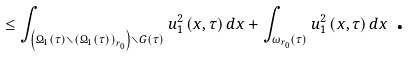Convert formula to latex. <formula><loc_0><loc_0><loc_500><loc_500>\leq \int \nolimits _ { \left ( \Omega _ { 1 } \left ( \tau \right ) \smallsetminus \left ( \Omega _ { 1 } \left ( \tau \right ) \right ) _ { r _ { 0 } } \right ) \smallsetminus G \left ( \tau \right ) } u _ { 1 } ^ { 2 } \left ( x , \tau \right ) d x + \int \nolimits _ { \omega _ { r _ { 0 } } \left ( \tau \right ) } u _ { 1 } ^ { 2 } \left ( x , \tau \right ) d x \text { .}</formula> 